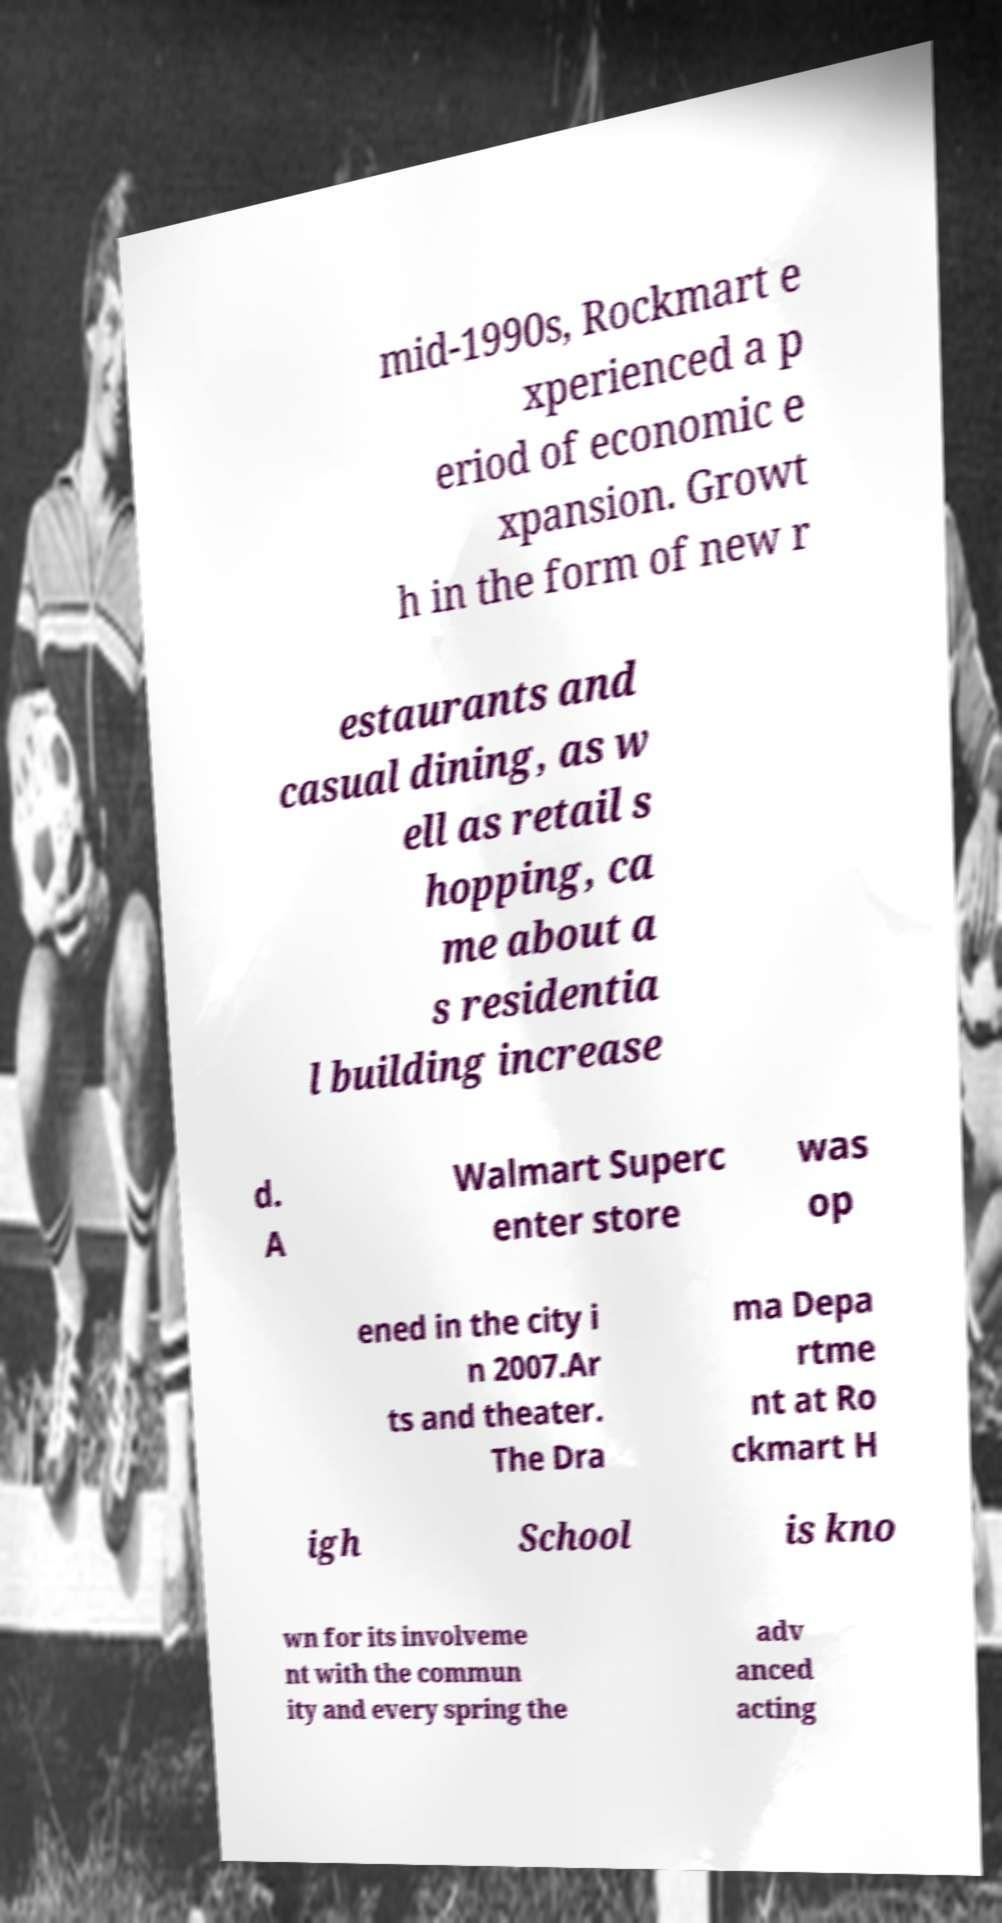Please identify and transcribe the text found in this image. mid-1990s, Rockmart e xperienced a p eriod of economic e xpansion. Growt h in the form of new r estaurants and casual dining, as w ell as retail s hopping, ca me about a s residentia l building increase d. A Walmart Superc enter store was op ened in the city i n 2007.Ar ts and theater. The Dra ma Depa rtme nt at Ro ckmart H igh School is kno wn for its involveme nt with the commun ity and every spring the adv anced acting 